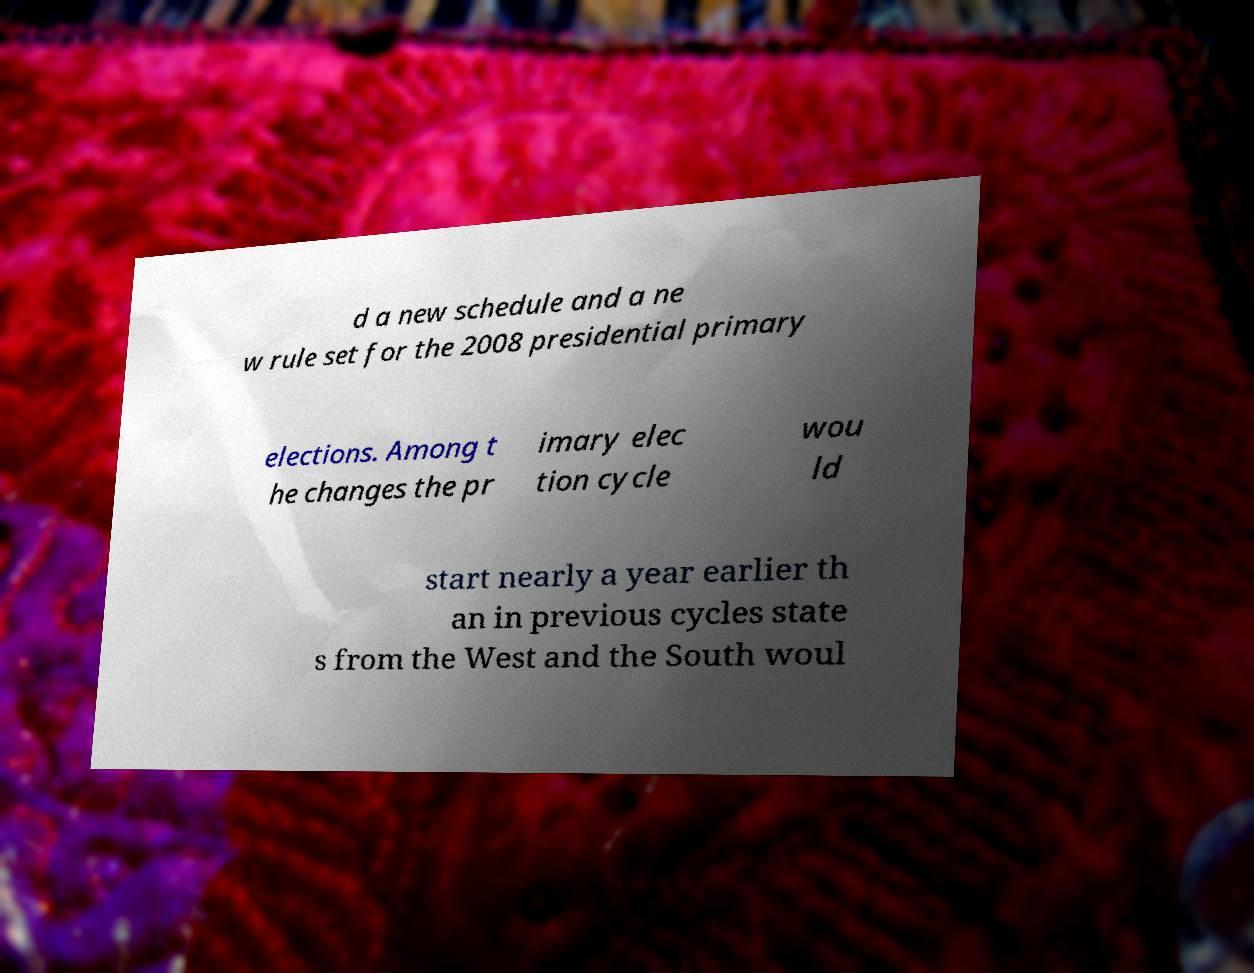Could you assist in decoding the text presented in this image and type it out clearly? d a new schedule and a ne w rule set for the 2008 presidential primary elections. Among t he changes the pr imary elec tion cycle wou ld start nearly a year earlier th an in previous cycles state s from the West and the South woul 